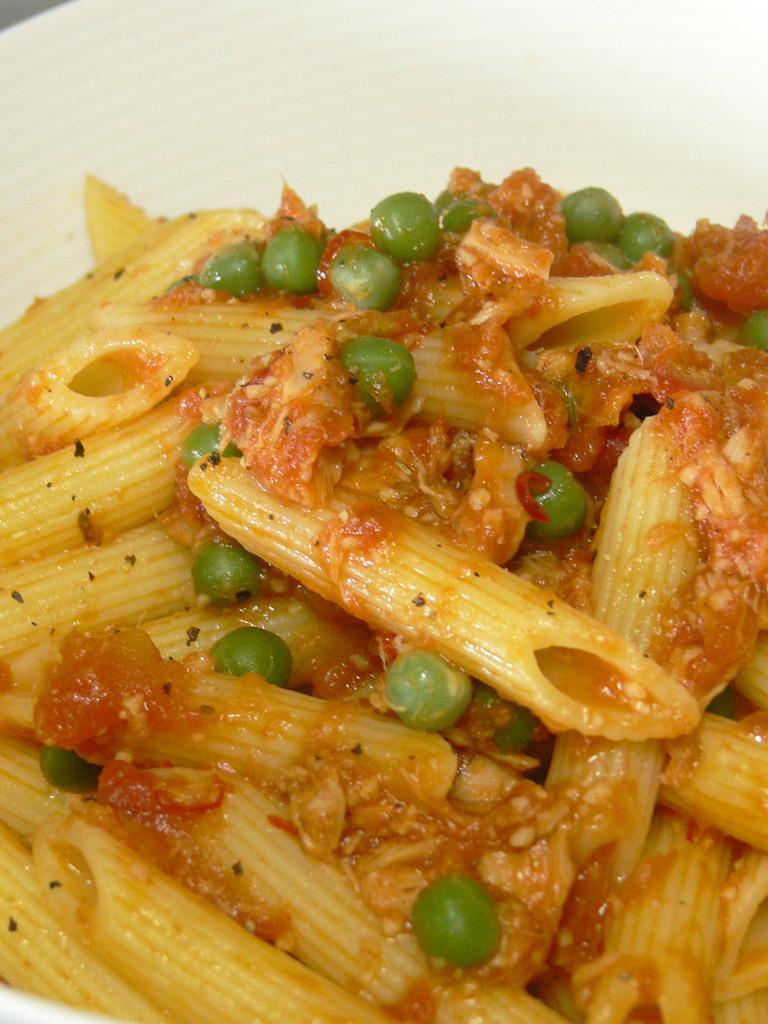Can you describe this image briefly? In the picture I can see a food item on the plate. 